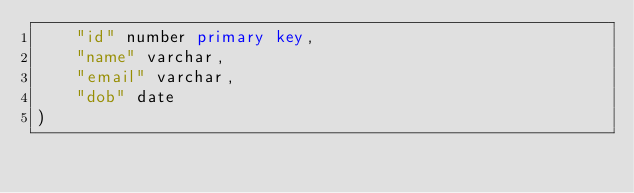Convert code to text. <code><loc_0><loc_0><loc_500><loc_500><_SQL_>    "id" number primary key,
    "name" varchar,
    "email" varchar,
    "dob" date
)</code> 